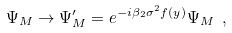Convert formula to latex. <formula><loc_0><loc_0><loc_500><loc_500>\Psi _ { M } \rightarrow \Psi _ { M } ^ { \prime } = e ^ { - i \beta _ { 2 } \sigma ^ { 2 } f ( y ) } \Psi _ { M } \ ,</formula> 